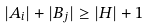Convert formula to latex. <formula><loc_0><loc_0><loc_500><loc_500>| A _ { i } | + | B _ { j } | \geq | H | + 1</formula> 